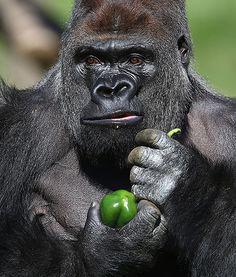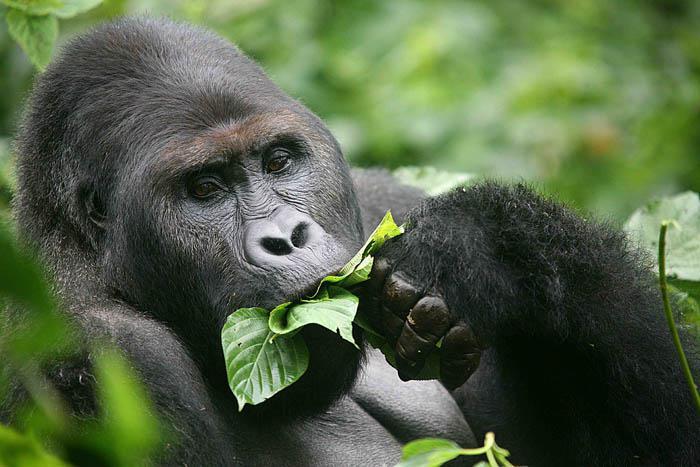The first image is the image on the left, the second image is the image on the right. Evaluate the accuracy of this statement regarding the images: "Each image shows a gorilla grasping edible plant material, and at least one image shows a gorilla chewing on the item.". Is it true? Answer yes or no. Yes. The first image is the image on the left, the second image is the image on the right. Considering the images on both sides, is "Only the image on the right depicts a gorilla holding food up to its mouth." valid? Answer yes or no. Yes. 